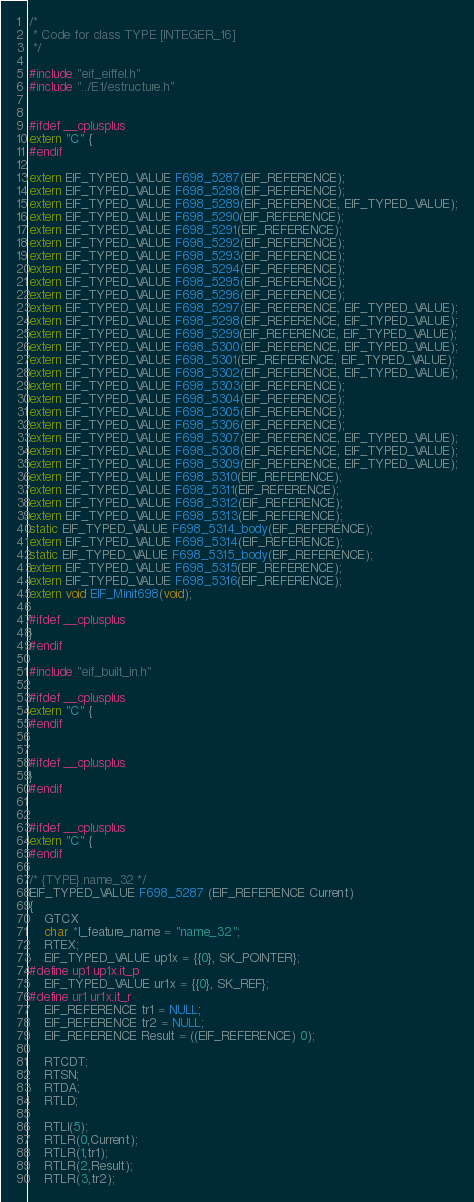Convert code to text. <code><loc_0><loc_0><loc_500><loc_500><_C_>/*
 * Code for class TYPE [INTEGER_16]
 */

#include "eif_eiffel.h"
#include "../E1/estructure.h"


#ifdef __cplusplus
extern "C" {
#endif

extern EIF_TYPED_VALUE F698_5287(EIF_REFERENCE);
extern EIF_TYPED_VALUE F698_5288(EIF_REFERENCE);
extern EIF_TYPED_VALUE F698_5289(EIF_REFERENCE, EIF_TYPED_VALUE);
extern EIF_TYPED_VALUE F698_5290(EIF_REFERENCE);
extern EIF_TYPED_VALUE F698_5291(EIF_REFERENCE);
extern EIF_TYPED_VALUE F698_5292(EIF_REFERENCE);
extern EIF_TYPED_VALUE F698_5293(EIF_REFERENCE);
extern EIF_TYPED_VALUE F698_5294(EIF_REFERENCE);
extern EIF_TYPED_VALUE F698_5295(EIF_REFERENCE);
extern EIF_TYPED_VALUE F698_5296(EIF_REFERENCE);
extern EIF_TYPED_VALUE F698_5297(EIF_REFERENCE, EIF_TYPED_VALUE);
extern EIF_TYPED_VALUE F698_5298(EIF_REFERENCE, EIF_TYPED_VALUE);
extern EIF_TYPED_VALUE F698_5299(EIF_REFERENCE, EIF_TYPED_VALUE);
extern EIF_TYPED_VALUE F698_5300(EIF_REFERENCE, EIF_TYPED_VALUE);
extern EIF_TYPED_VALUE F698_5301(EIF_REFERENCE, EIF_TYPED_VALUE);
extern EIF_TYPED_VALUE F698_5302(EIF_REFERENCE, EIF_TYPED_VALUE);
extern EIF_TYPED_VALUE F698_5303(EIF_REFERENCE);
extern EIF_TYPED_VALUE F698_5304(EIF_REFERENCE);
extern EIF_TYPED_VALUE F698_5305(EIF_REFERENCE);
extern EIF_TYPED_VALUE F698_5306(EIF_REFERENCE);
extern EIF_TYPED_VALUE F698_5307(EIF_REFERENCE, EIF_TYPED_VALUE);
extern EIF_TYPED_VALUE F698_5308(EIF_REFERENCE, EIF_TYPED_VALUE);
extern EIF_TYPED_VALUE F698_5309(EIF_REFERENCE, EIF_TYPED_VALUE);
extern EIF_TYPED_VALUE F698_5310(EIF_REFERENCE);
extern EIF_TYPED_VALUE F698_5311(EIF_REFERENCE);
extern EIF_TYPED_VALUE F698_5312(EIF_REFERENCE);
extern EIF_TYPED_VALUE F698_5313(EIF_REFERENCE);
static EIF_TYPED_VALUE F698_5314_body(EIF_REFERENCE);
extern EIF_TYPED_VALUE F698_5314(EIF_REFERENCE);
static EIF_TYPED_VALUE F698_5315_body(EIF_REFERENCE);
extern EIF_TYPED_VALUE F698_5315(EIF_REFERENCE);
extern EIF_TYPED_VALUE F698_5316(EIF_REFERENCE);
extern void EIF_Minit698(void);

#ifdef __cplusplus
}
#endif

#include "eif_built_in.h"

#ifdef __cplusplus
extern "C" {
#endif


#ifdef __cplusplus
}
#endif


#ifdef __cplusplus
extern "C" {
#endif

/* {TYPE}.name_32 */
EIF_TYPED_VALUE F698_5287 (EIF_REFERENCE Current)
{
	GTCX
	char *l_feature_name = "name_32";
	RTEX;
	EIF_TYPED_VALUE up1x = {{0}, SK_POINTER};
#define up1 up1x.it_p
	EIF_TYPED_VALUE ur1x = {{0}, SK_REF};
#define ur1 ur1x.it_r
	EIF_REFERENCE tr1 = NULL;
	EIF_REFERENCE tr2 = NULL;
	EIF_REFERENCE Result = ((EIF_REFERENCE) 0);
	
	RTCDT;
	RTSN;
	RTDA;
	RTLD;
	
	RTLI(5);
	RTLR(0,Current);
	RTLR(1,tr1);
	RTLR(2,Result);
	RTLR(3,tr2);</code> 